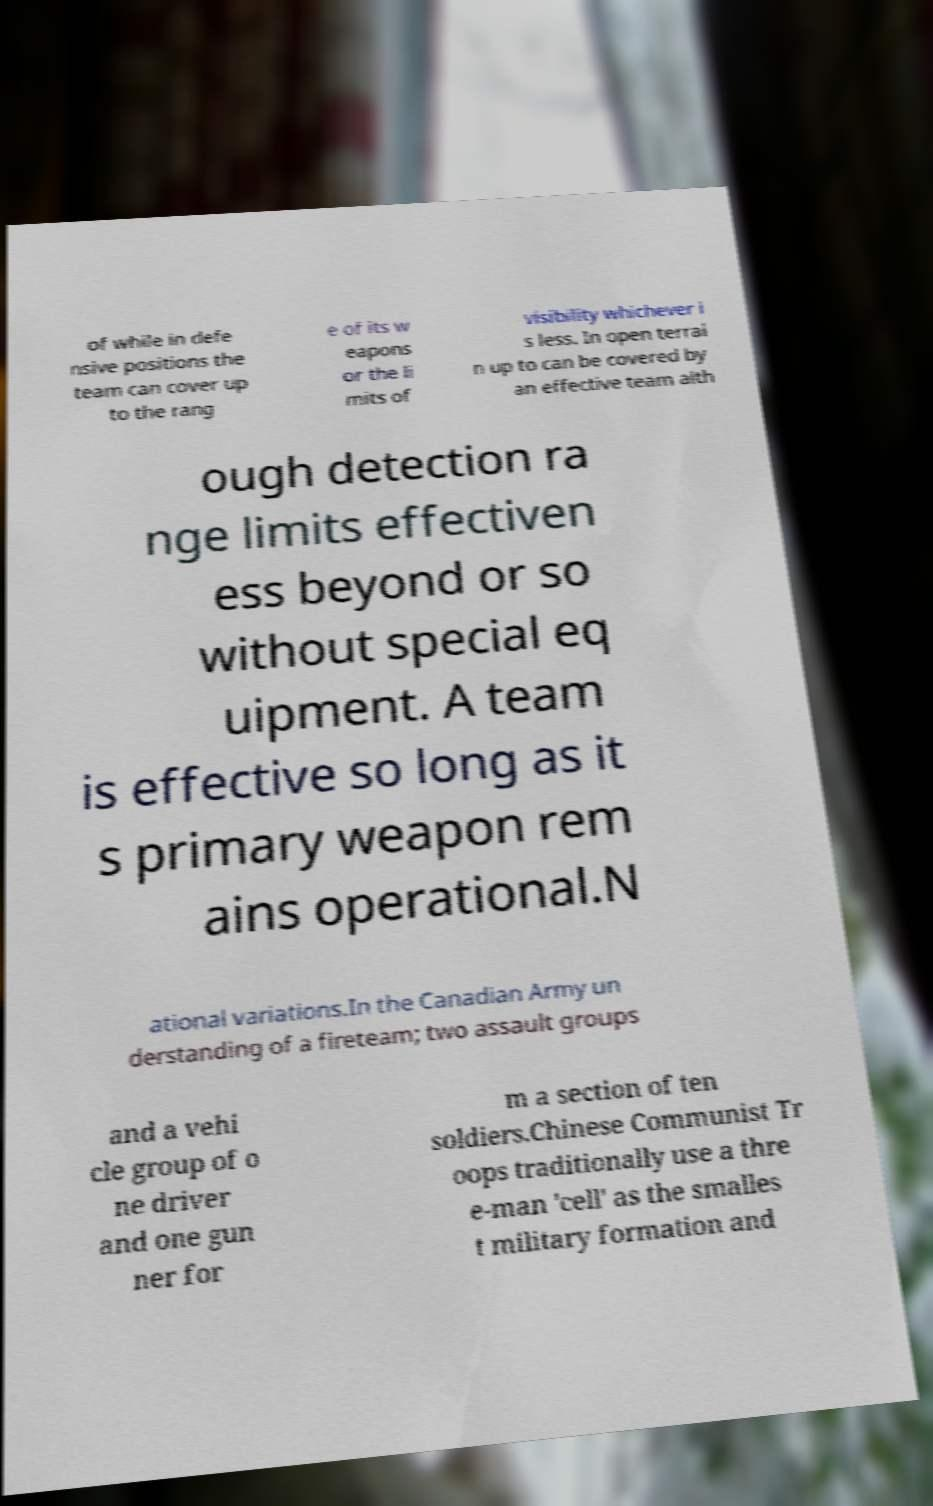Please read and relay the text visible in this image. What does it say? of while in defe nsive positions the team can cover up to the rang e of its w eapons or the li mits of visibility whichever i s less. In open terrai n up to can be covered by an effective team alth ough detection ra nge limits effectiven ess beyond or so without special eq uipment. A team is effective so long as it s primary weapon rem ains operational.N ational variations.In the Canadian Army un derstanding of a fireteam; two assault groups and a vehi cle group of o ne driver and one gun ner for m a section of ten soldiers.Chinese Communist Tr oops traditionally use a thre e-man 'cell' as the smalles t military formation and 